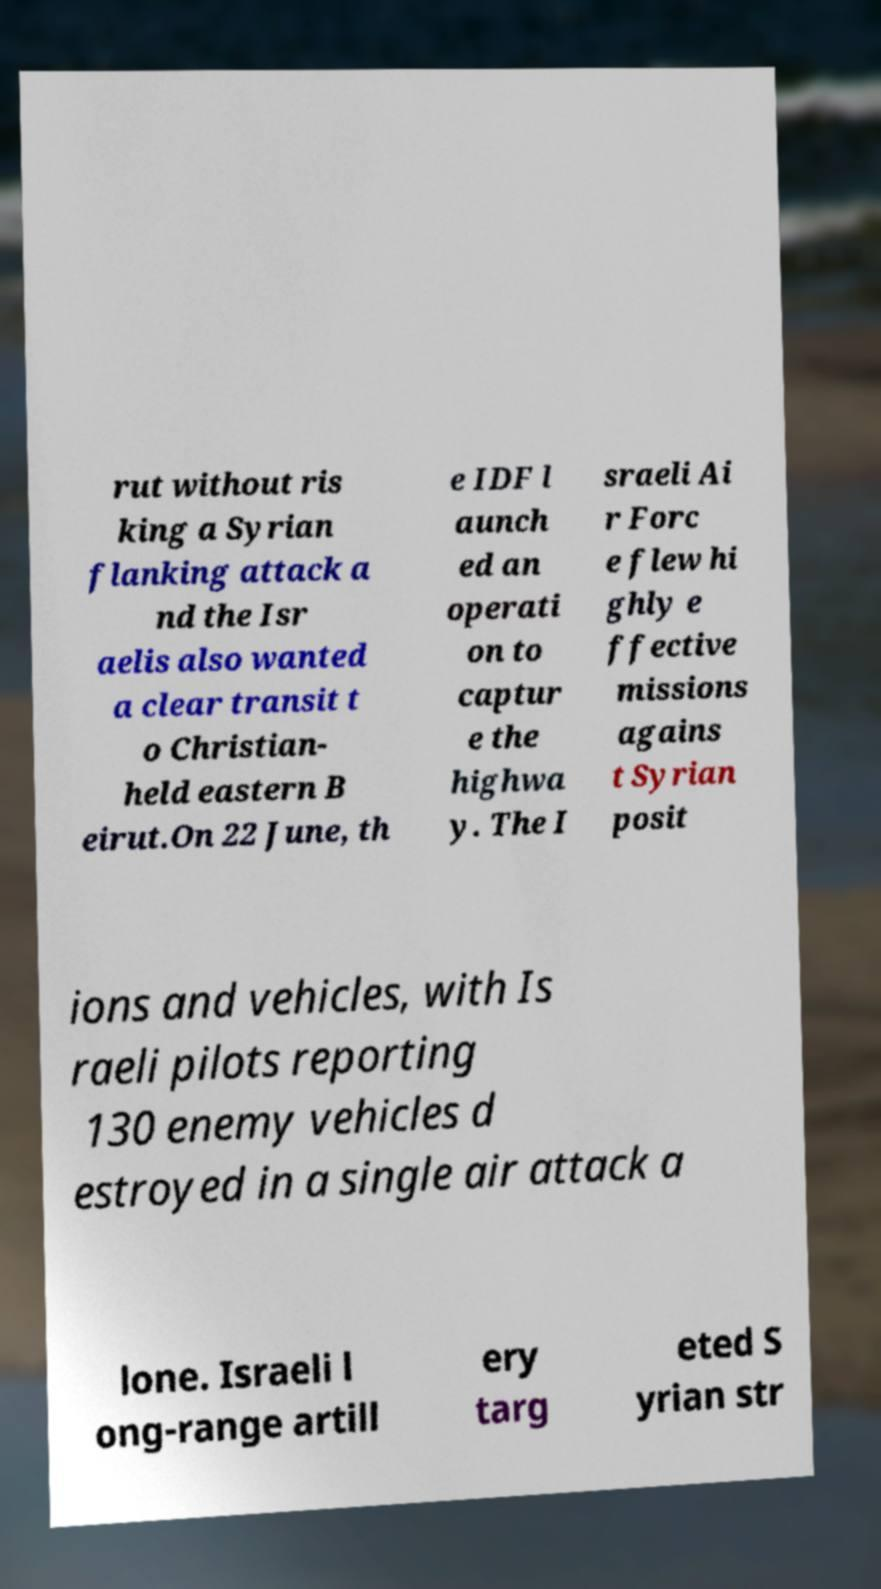Can you accurately transcribe the text from the provided image for me? rut without ris king a Syrian flanking attack a nd the Isr aelis also wanted a clear transit t o Christian- held eastern B eirut.On 22 June, th e IDF l aunch ed an operati on to captur e the highwa y. The I sraeli Ai r Forc e flew hi ghly e ffective missions agains t Syrian posit ions and vehicles, with Is raeli pilots reporting 130 enemy vehicles d estroyed in a single air attack a lone. Israeli l ong-range artill ery targ eted S yrian str 